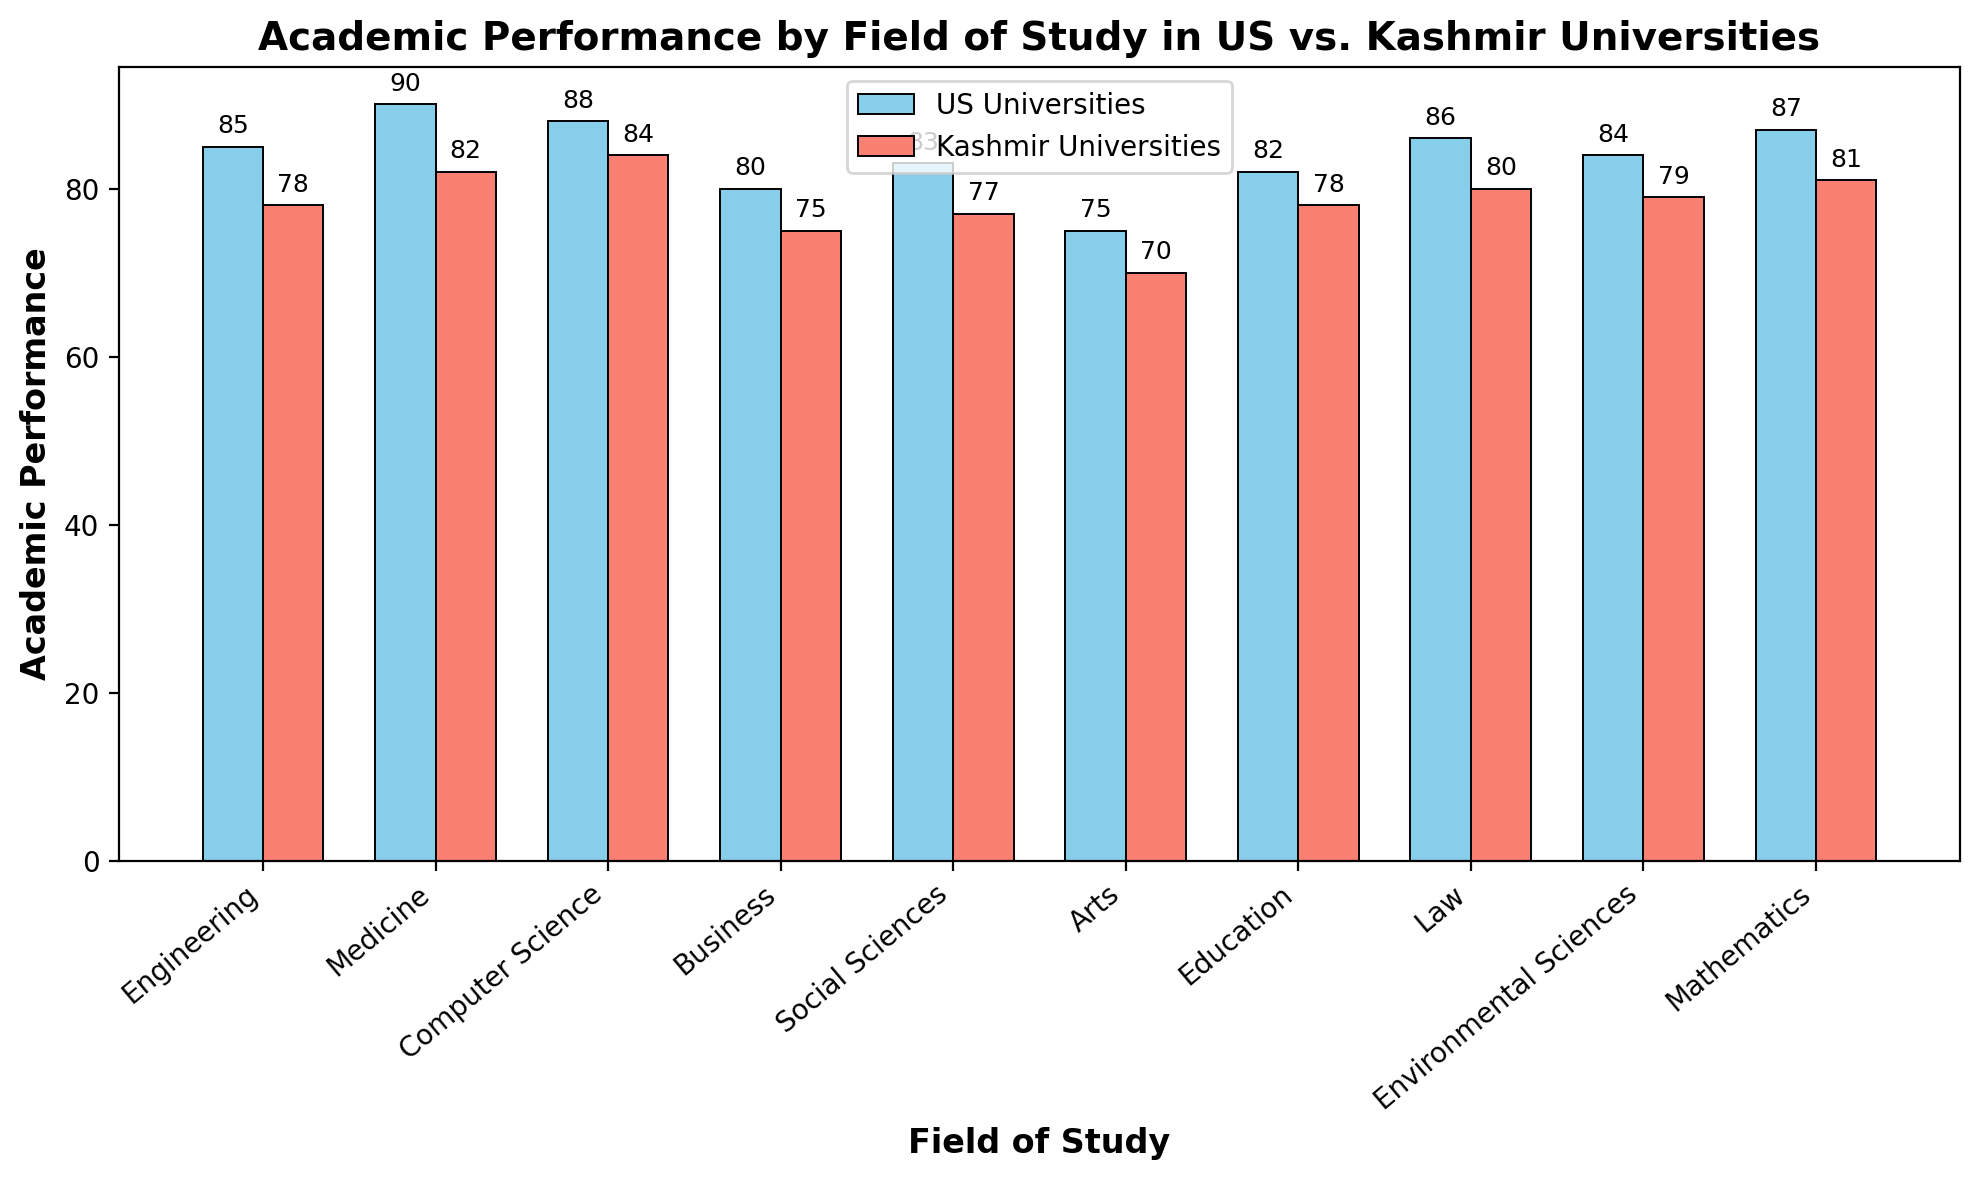Which field of study has the highest academic performance in both US and Kashmir universities? The highest academic performance in US universities is in Medicine (90), and in Kashmir universities, it is also Medicine (82).
Answer: Medicine in both Which field of study has the lowest academic performance in US universities? The lowest academic performance in US universities is in Arts with a score of 75.
Answer: Arts By how many points does Academic Performance in Medicine in US universities exceed that in Kashmir universities? US universities' score for Medicine is 90 and Kashmir universities' score is 82, so the difference is 90 - 82 = 8 points.
Answer: 8 What is the average academic performance score across all fields of study in Kashmir universities? Summing the scores: 78 + 82 + 84 + 75 + 77 + 70 + 78 + 80 + 79 + 81 = 784. There are 10 fields of study, so the average is 784 / 10 = 78.4.
Answer: 78.4 Which fields of study have a higher academic performance in Kashmir universities compared to US universities? By visually comparing the heights of the bars, none of the fields of study in Kashmir universities have a higher performance than in US universities.
Answer: None Which field has the smallest difference in academic performance between US and Kashmir universities? Visual inspection shows that the difference between US and Kashmir universities' scores is smallest for Computer Science, which is 88 - 84 = 4 points.
Answer: Computer Science How much higher is the average academic performance in US universities compared to Kashmir universities across all fields? Average in US: (85 + 90 + 88 + 80 + 83 + 75 + 82 + 86 + 84 + 87)/10 = 84. Average in Kashmir: (78 + 82 + 84 + 75 + 77 + 70 + 78 + 80 + 79 + 81)/10 = 78.4. The difference is 84 - 78.4 = 5.6.
Answer: 5.6 Which field shows the greatest disparity in academic performance between the two regions? Visual inspection indicates that Medicine has the greatest disparity, with a difference of 90 - 82 = 8 points.
Answer: Medicine How does the performance in Environmental Sciences compare between US and Kashmir universities? US universities have a score of 84 in Environmental Sciences, while Kashmir universities have 79. US universities outperform by 84 - 79 = 5 points.
Answer: US universities perform 5 points better 